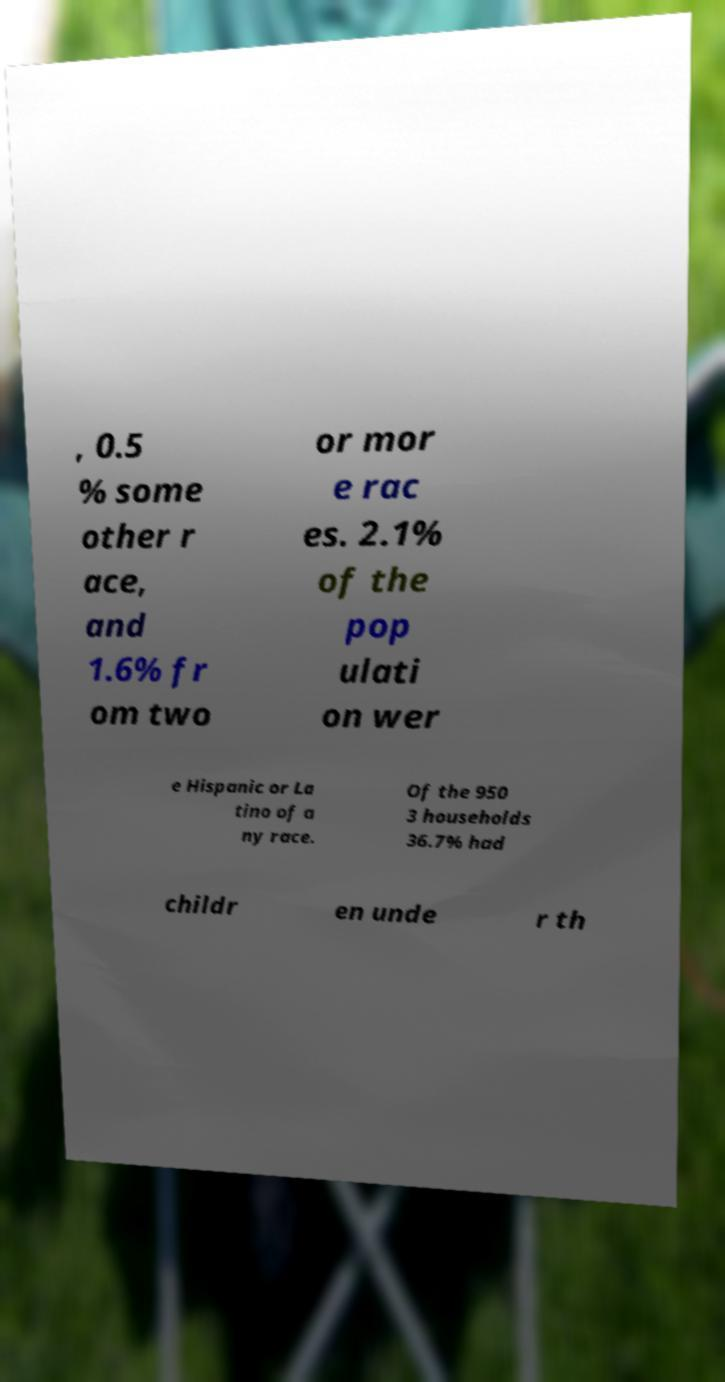Could you assist in decoding the text presented in this image and type it out clearly? , 0.5 % some other r ace, and 1.6% fr om two or mor e rac es. 2.1% of the pop ulati on wer e Hispanic or La tino of a ny race. Of the 950 3 households 36.7% had childr en unde r th 